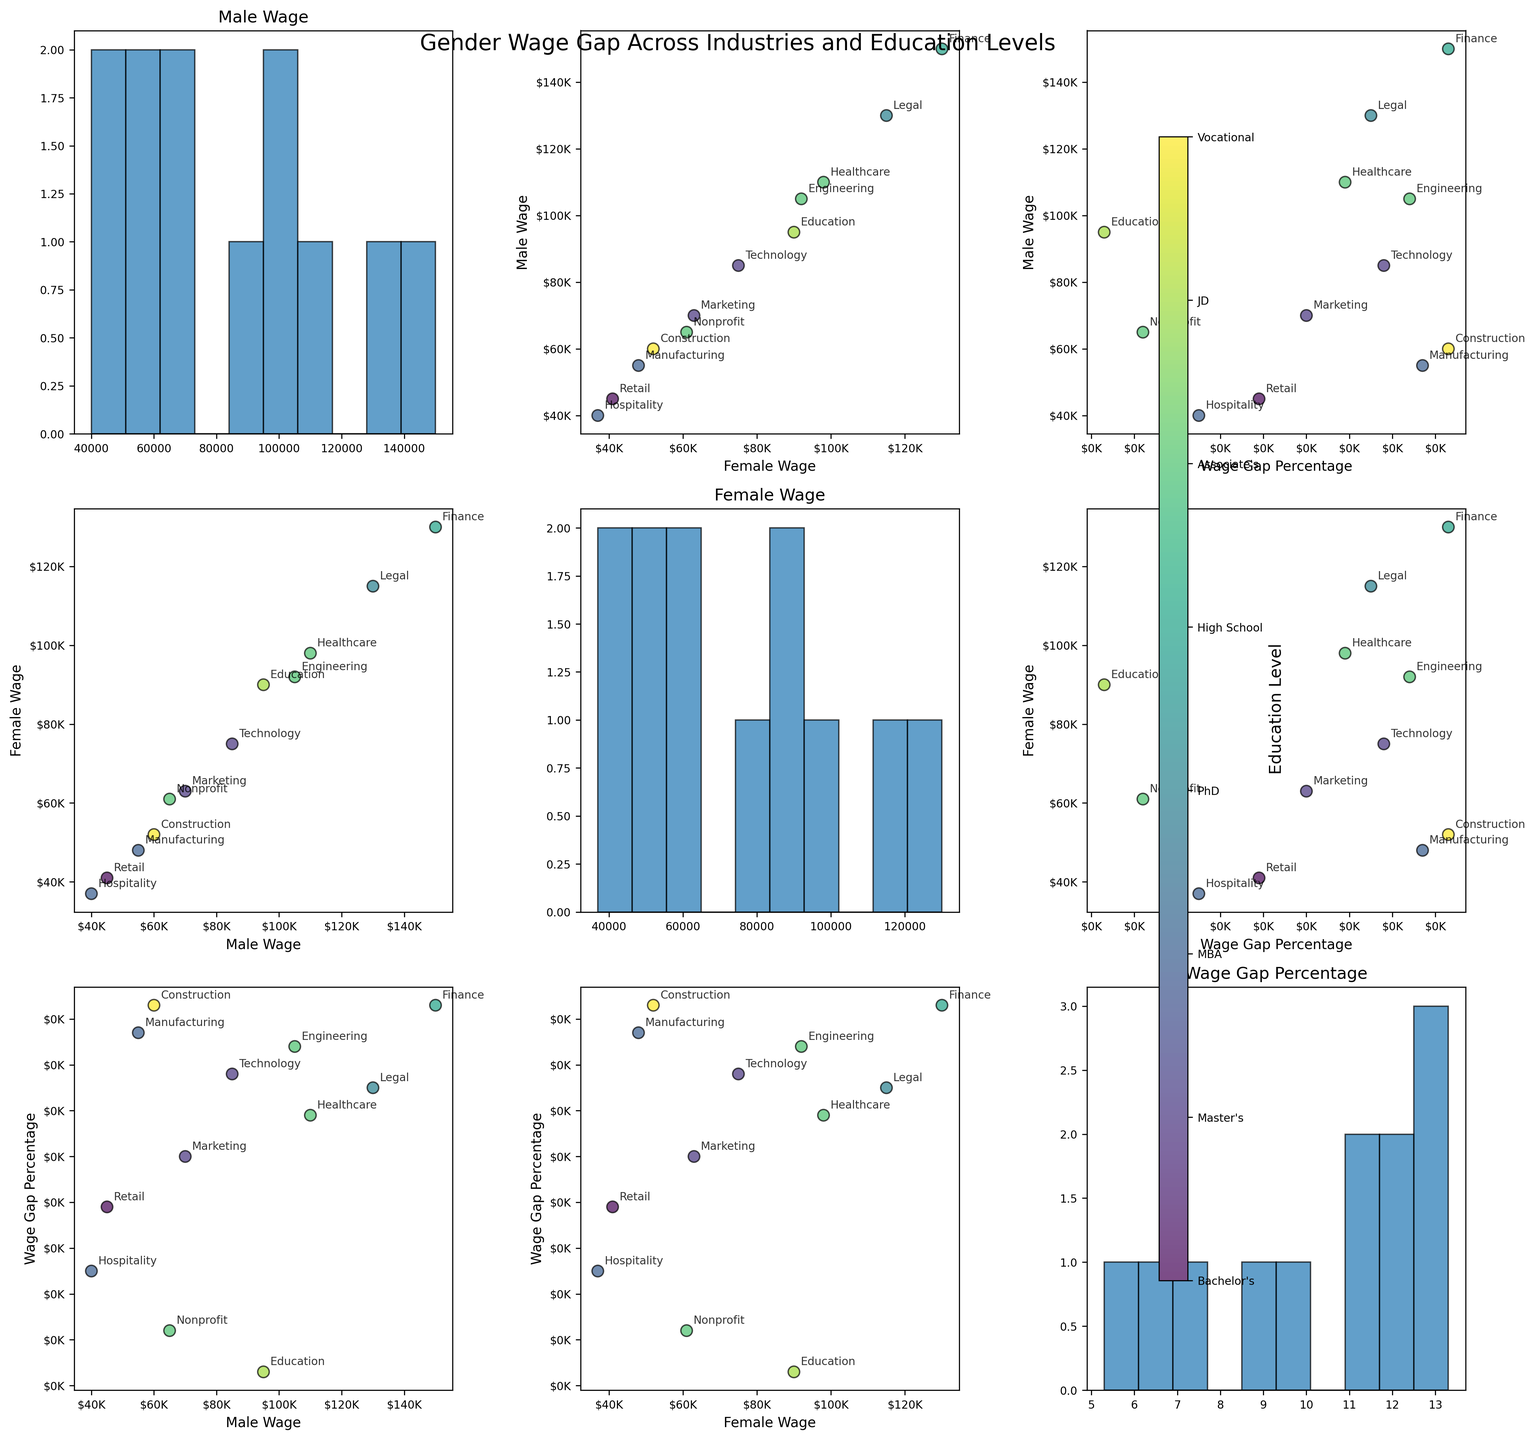How many variables are plotted in the scatterplot matrix? There are three variables plotted: Male Wage, Female Wage, and Wage Gap Percentage. This information is gathered from the code where the variables are assigned to the 'variables' list.
Answer: 3 What education level has the highest male wage in the dataset? By examining the scatter plots that compare Male Wage with other variables, the highest male wage falls within the Finance industry with an MBA education level. The exact figure is $150K.
Answer: MBA What industry exhibits the smallest wage gap percentage? From observing the scatter plots comparing Wage Gap Percentage, the smallest wage gap percentage is 5.3%, which corresponds to the Education industry with a PhD education level.
Answer: Education What is the education level for the industry with the highest female wage? The highest female wage can be seen in the scatter plots comparing Female Wage. The industry with the highest female wage is Finance, and the education level is MBA, with a female wage of $130K.
Answer: MBA Which industry has the lowest female wage and what is the amount? The lowest female wage is found by looking at the scatter plots involving Female Wage. The Retail industry with an Associate's education level has the lowest female wage at $41K.
Answer: Retail How does the wage gap in the Technology industry compare to the wage gap in Construction? By inspecting the scatter plots that include Wage Gap Percentage, the Technology industry has a wage gap of 11.8%, while the Construction industry has a wage gap of 13.3%. The Construction industry therefore has a higher wage gap.
Answer: Construction industry has a higher wage gap Is there a clear trend between the type of education level and the wage gap percentage? By examining the scatter plots and color bar representing Education Level, there is no immediately clear trend showing a consistent relationship between different education levels and the wage gap percentage.
Answer: No clear trend Which industry has a higher wage gap, Healthcare or Marketing, and by how much? By examining the scatter plots with Wage Gap Percentage, Healthcare has a wage gap of 10.9% while Marketing has a wage gap of 10.0%. The Healthcare industry's wage gap is higher by 0.9%.
Answer: Healthcare, 0.9% What is the relationship between male wage and female wage in the Engineering industry? Observing the scatter plots comparing Male Wage and Female Wage, the dot representing the Engineering industry shows a male wage of $105K and a female wage of $92K. The relationship is that the male wage is higher.
Answer: Male wage is higher What is the average male wage for industries requiring a Master's degree? In the scatter plots, the Male Wages for industries with a Master's degree (Healthcare, Engineering, and Nonprofit) are $110K, $105K, and $65K respectively. The average is calculated as (110 + 105 + 65) / 3 = 280 / 3 ≈ $93.3K.
Answer: $93.3K 